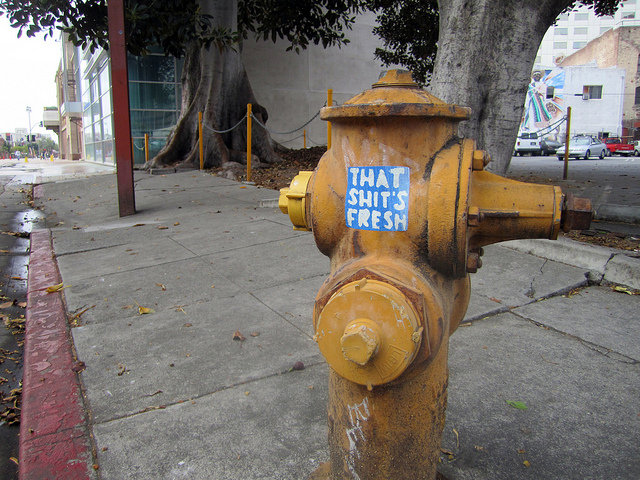Identify the text displayed in this image. THAT SHIT'S FRESH BE 